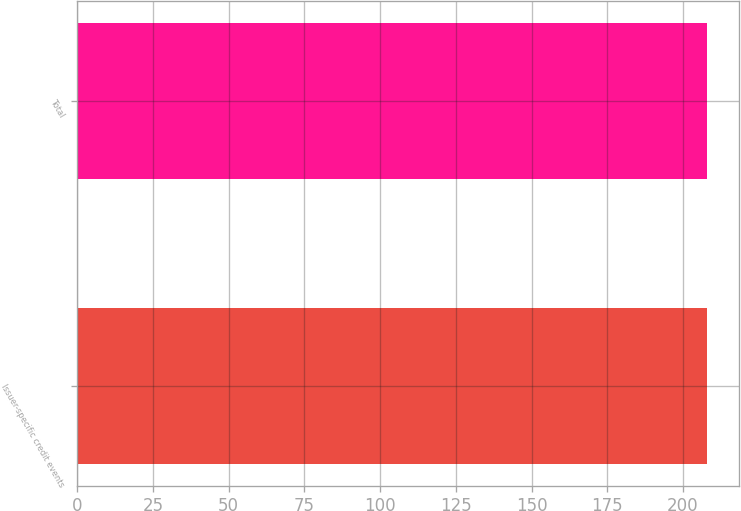<chart> <loc_0><loc_0><loc_500><loc_500><bar_chart><fcel>Issuer-specific credit events<fcel>Total<nl><fcel>208<fcel>208.1<nl></chart> 